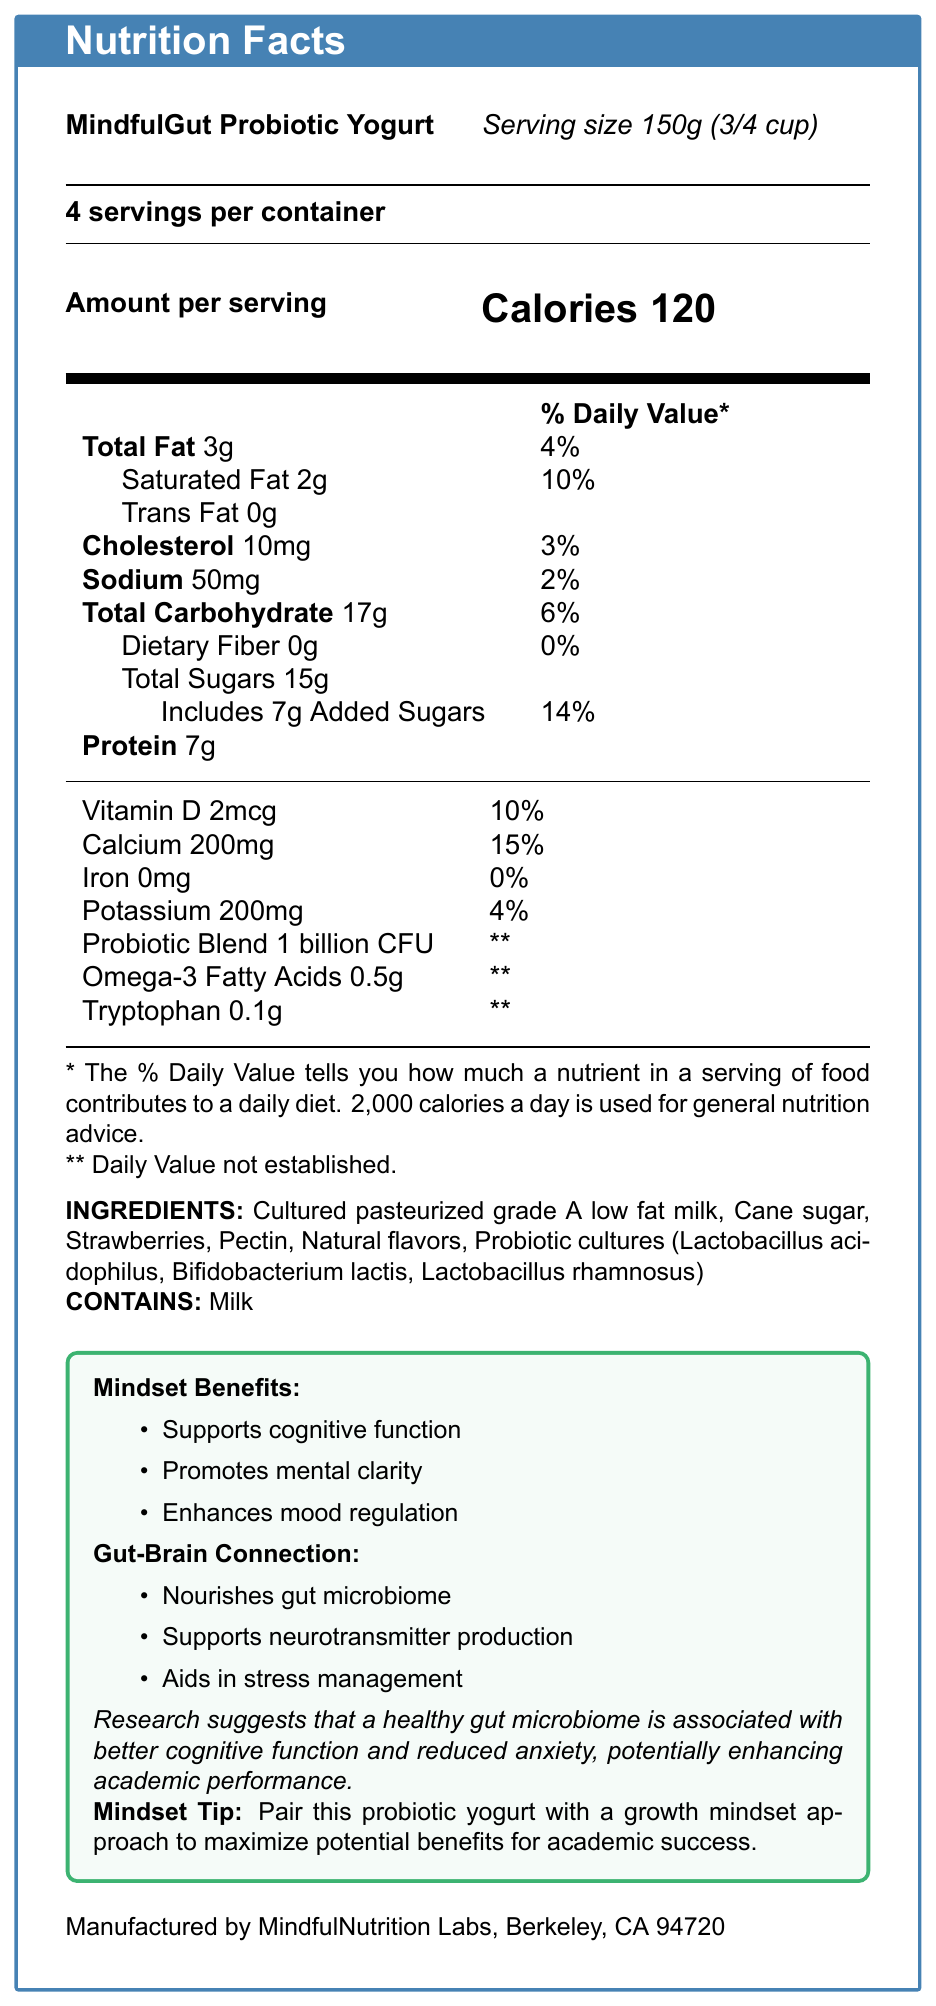How many servings are in the container? The document states that there are 4 servings per container.
Answer: 4 servings What is the calorie content per serving? The document specifies that the amount per serving is 120 calories.
Answer: 120 calories Which ingredient in the yogurt is listed first? The document lists "Cultured pasteurized grade A low fat milk" as the first ingredient.
Answer: Cultured pasteurized grade A low fat milk What are the three probiotic strains in the MindfulGut Probiotic Yogurt? The document lists these three strains explicitly under probiotic cultures.
Answer: Lactobacillus acidophilus, Bifidobacterium lactis, Lactobacillus rhamnosus How much protein is there per serving? The amount of protein per serving as shown in the document is 7g.
Answer: 7g What percentage of the daily value of calcium does one serving provide? The document indicates that one serving provides 15% of the daily value of calcium.
Answer: 15% Does the yogurt contain any iron? The document lists iron content as 0mg, which means it contains no iron.
Answer: No Which of the following is NOT a benefit listed under "Gut-Brain Connection"? a. Nourishes gut microbiome b. Supports neurotransmitter production c. Increases physical strength d. Aids in stress management The document lists "Nourishes gut microbiome," "Supports neurotransmitter production," and "Aids in stress management," but not "Increases physical strength."
Answer: c. Increases physical strength Which vitamin in the yogurt has an established daily value percentage? a. Vitamin A b. Vitamin D c. Vitamin C d. Vitamin B12 The document lists Vitamin D with 10% of the daily value, while others are either not mentioned or have no established daily value.
Answer: b. Vitamin D Is this yogurt suitable for someone who is lactose intolerant? The yogurt contains milk, which is indicated in the allergen information section.
Answer: No Summarize the benefits of consuming MindfulGut Probiotic Yogurt for academic performance. The document explains that the yogurt supports cognitive function, promotes mental clarity, and enhances mood regulation, which can lead to better academic performance, especially when paired with a growth mindset approach.
Answer: Regular consumption of MindfulGut Probiotic Yogurt may contribute to improved focus, mental resilience, and cognitive function due to its positive impact on gut health and mental clarity. How much tryptophan is in one serving of yogurt? The document specifies that there is 0.1g of tryptophan per serving.
Answer: 0.1g What is the daily value percentage for Omega-3 fatty acids provided by the yogurt? The document indicates that the daily value percentage for Omega-3 fatty acids is not established, denoted by **.
Answer: Not established Can we determine the exact sugar content from natural sources other than added sugars in this yogurt? The document lists total sugars and added sugars but does not provide a breakdown of natural sugar content specifically.
Answer: No What is the primary location of the manufacturer? The document lists the manufacturer as MindfulNutrition Labs, Berkeley, CA 94720.
Answer: Berkeley, CA 94720 